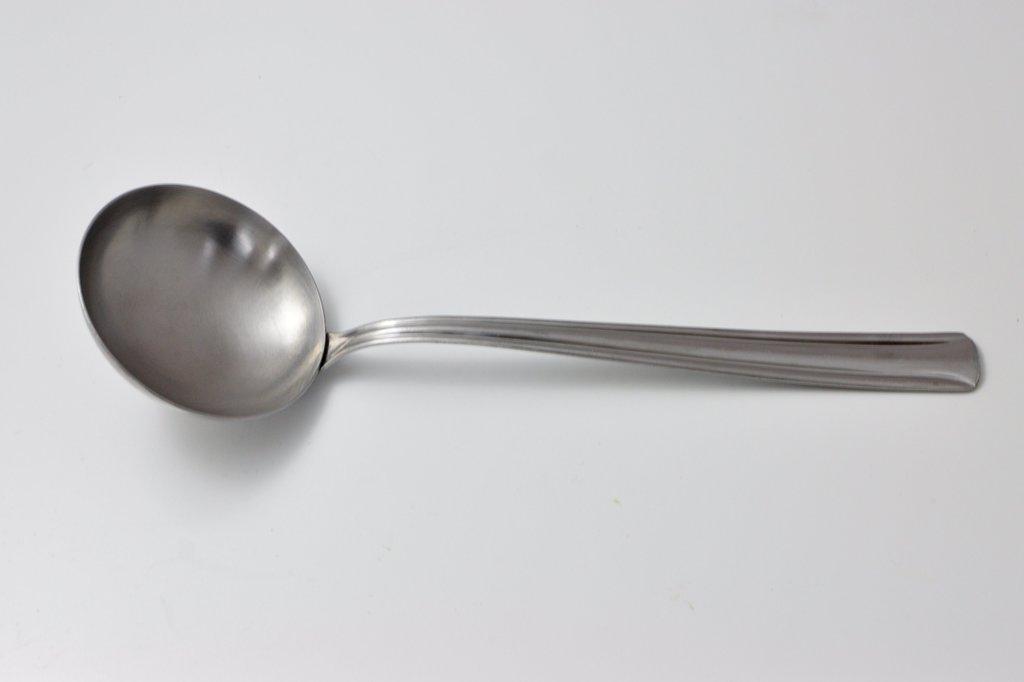How would you summarize this image in a sentence or two? In this image I can see a metal spoon which is grey in color is on the white colored surface. 